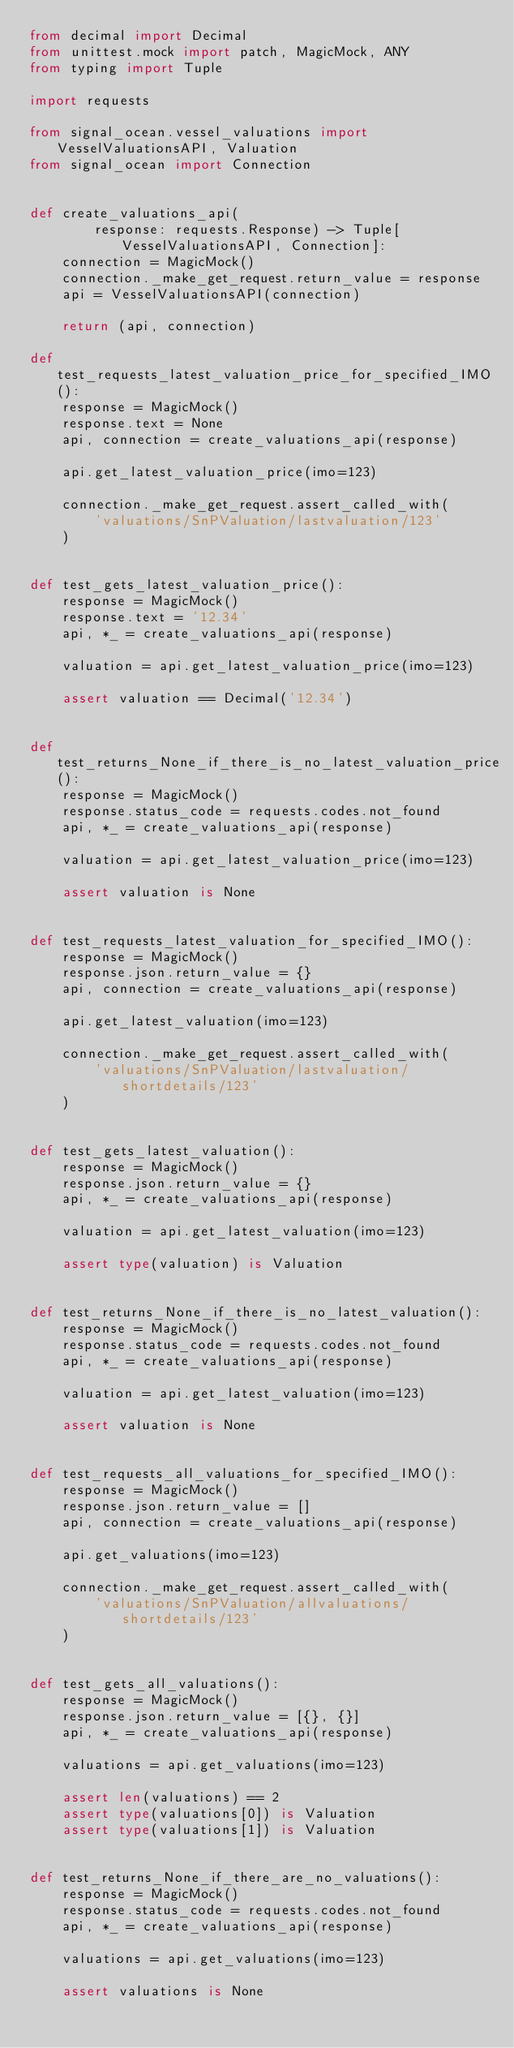Convert code to text. <code><loc_0><loc_0><loc_500><loc_500><_Python_>from decimal import Decimal
from unittest.mock import patch, MagicMock, ANY
from typing import Tuple

import requests

from signal_ocean.vessel_valuations import VesselValuationsAPI, Valuation
from signal_ocean import Connection


def create_valuations_api(
        response: requests.Response) -> Tuple[VesselValuationsAPI, Connection]:
    connection = MagicMock()
    connection._make_get_request.return_value = response
    api = VesselValuationsAPI(connection)

    return (api, connection)

def test_requests_latest_valuation_price_for_specified_IMO():
    response = MagicMock()
    response.text = None
    api, connection = create_valuations_api(response)

    api.get_latest_valuation_price(imo=123)

    connection._make_get_request.assert_called_with(
        'valuations/SnPValuation/lastvaluation/123'
    )


def test_gets_latest_valuation_price():
    response = MagicMock()
    response.text = '12.34'
    api, *_ = create_valuations_api(response)

    valuation = api.get_latest_valuation_price(imo=123)

    assert valuation == Decimal('12.34')


def test_returns_None_if_there_is_no_latest_valuation_price():
    response = MagicMock()
    response.status_code = requests.codes.not_found
    api, *_ = create_valuations_api(response)

    valuation = api.get_latest_valuation_price(imo=123)

    assert valuation is None


def test_requests_latest_valuation_for_specified_IMO():
    response = MagicMock()
    response.json.return_value = {}
    api, connection = create_valuations_api(response)

    api.get_latest_valuation(imo=123)

    connection._make_get_request.assert_called_with(
        'valuations/SnPValuation/lastvaluation/shortdetails/123'
    )


def test_gets_latest_valuation():
    response = MagicMock()
    response.json.return_value = {}
    api, *_ = create_valuations_api(response)

    valuation = api.get_latest_valuation(imo=123)

    assert type(valuation) is Valuation


def test_returns_None_if_there_is_no_latest_valuation():
    response = MagicMock()
    response.status_code = requests.codes.not_found
    api, *_ = create_valuations_api(response)

    valuation = api.get_latest_valuation(imo=123)

    assert valuation is None


def test_requests_all_valuations_for_specified_IMO():
    response = MagicMock()
    response.json.return_value = []
    api, connection = create_valuations_api(response)

    api.get_valuations(imo=123)

    connection._make_get_request.assert_called_with(
        'valuations/SnPValuation/allvaluations/shortdetails/123'
    )


def test_gets_all_valuations():
    response = MagicMock()
    response.json.return_value = [{}, {}]
    api, *_ = create_valuations_api(response)

    valuations = api.get_valuations(imo=123)

    assert len(valuations) == 2
    assert type(valuations[0]) is Valuation
    assert type(valuations[1]) is Valuation


def test_returns_None_if_there_are_no_valuations():
    response = MagicMock()
    response.status_code = requests.codes.not_found
    api, *_ = create_valuations_api(response)

    valuations = api.get_valuations(imo=123)

    assert valuations is None
</code> 